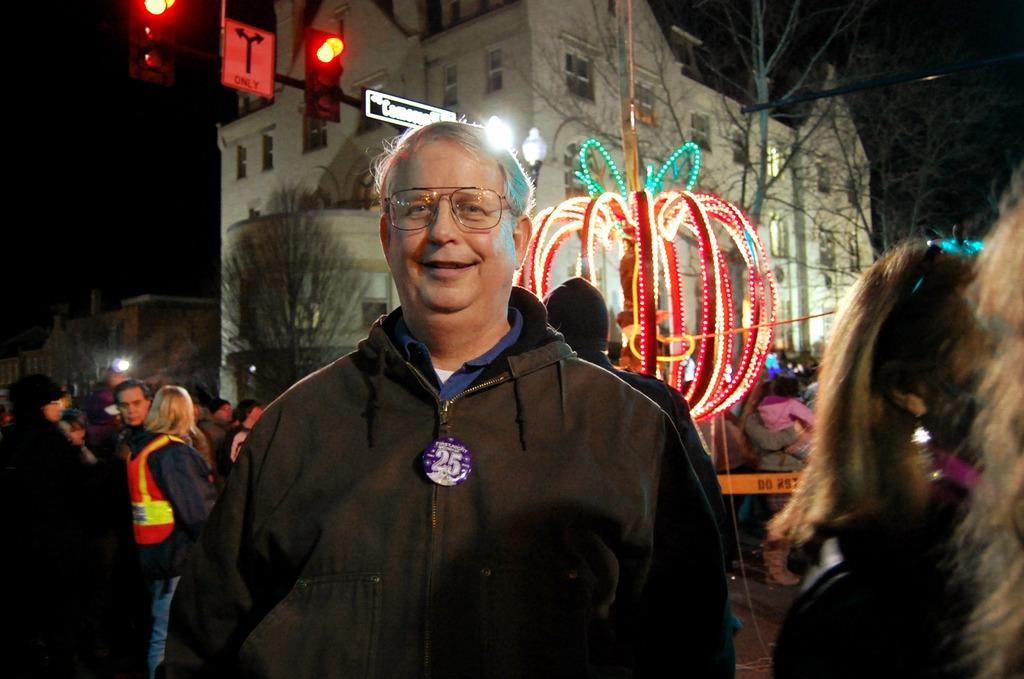Who is the main subject in the image? There is a person in the center of the image. What can be seen in the background of the image? There is lighting, other persons, a building, more lighting, traffic signals, and the sky visible in the background of the image. Can you describe the lighting in the background of the image? There is lighting in the background of the image, and it appears to be brighter than the lighting on the person in the center. What else is present in the background of the image? There are traffic signals in the background of the image. What is the chance of the person in the image winning a motion-based journey in the near future? There is no information about the person's chances of winning a motion-based journey in the image or the provided facts. 